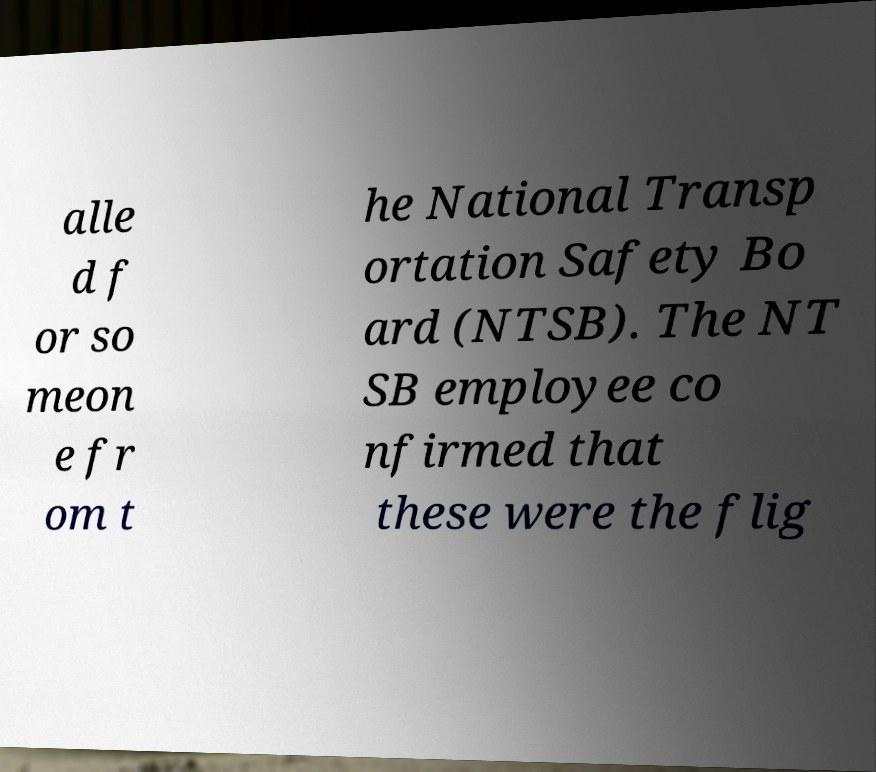There's text embedded in this image that I need extracted. Can you transcribe it verbatim? alle d f or so meon e fr om t he National Transp ortation Safety Bo ard (NTSB). The NT SB employee co nfirmed that these were the flig 